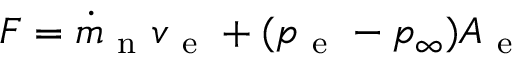Convert formula to latex. <formula><loc_0><loc_0><loc_500><loc_500>F = \dot { m } _ { n } v _ { e } + ( p _ { e } - p _ { \infty } ) A _ { e }</formula> 